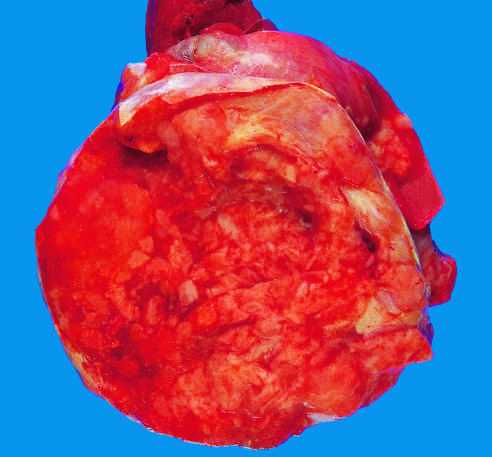re the nuclei large and hyperchromatic?
Answer the question using a single word or phrase. Yes 